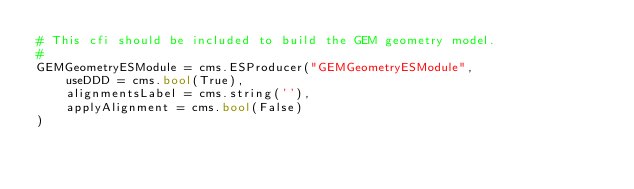<code> <loc_0><loc_0><loc_500><loc_500><_Python_># This cfi should be included to build the GEM geometry model.
#
GEMGeometryESModule = cms.ESProducer("GEMGeometryESModule",
    useDDD = cms.bool(True),
    alignmentsLabel = cms.string(''),
    applyAlignment = cms.bool(False)
)
</code> 